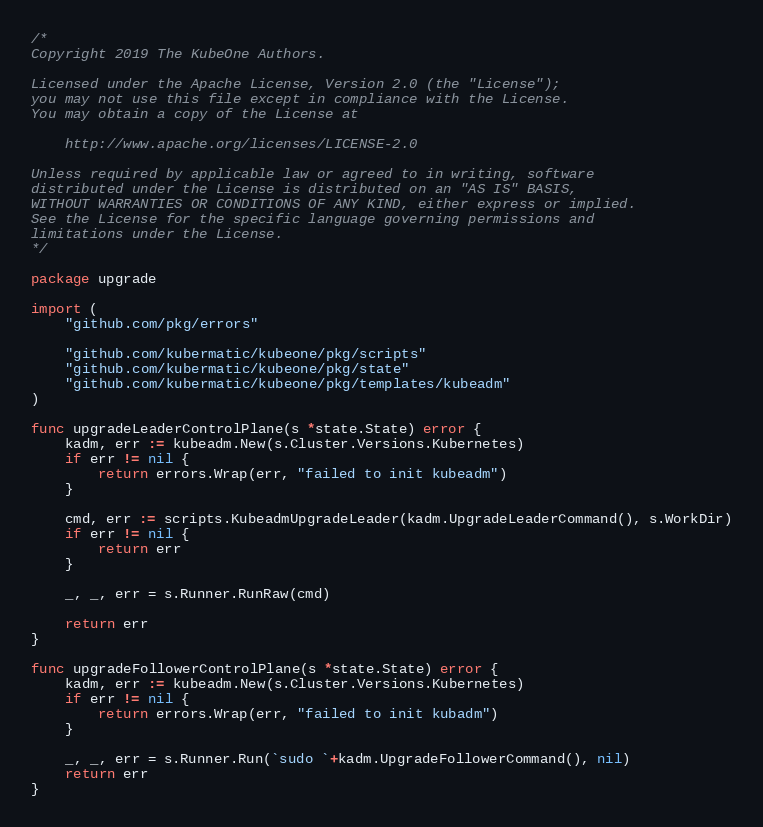Convert code to text. <code><loc_0><loc_0><loc_500><loc_500><_Go_>/*
Copyright 2019 The KubeOne Authors.

Licensed under the Apache License, Version 2.0 (the "License");
you may not use this file except in compliance with the License.
You may obtain a copy of the License at

    http://www.apache.org/licenses/LICENSE-2.0

Unless required by applicable law or agreed to in writing, software
distributed under the License is distributed on an "AS IS" BASIS,
WITHOUT WARRANTIES OR CONDITIONS OF ANY KIND, either express or implied.
See the License for the specific language governing permissions and
limitations under the License.
*/

package upgrade

import (
	"github.com/pkg/errors"

	"github.com/kubermatic/kubeone/pkg/scripts"
	"github.com/kubermatic/kubeone/pkg/state"
	"github.com/kubermatic/kubeone/pkg/templates/kubeadm"
)

func upgradeLeaderControlPlane(s *state.State) error {
	kadm, err := kubeadm.New(s.Cluster.Versions.Kubernetes)
	if err != nil {
		return errors.Wrap(err, "failed to init kubeadm")
	}

	cmd, err := scripts.KubeadmUpgradeLeader(kadm.UpgradeLeaderCommand(), s.WorkDir)
	if err != nil {
		return err
	}

	_, _, err = s.Runner.RunRaw(cmd)

	return err
}

func upgradeFollowerControlPlane(s *state.State) error {
	kadm, err := kubeadm.New(s.Cluster.Versions.Kubernetes)
	if err != nil {
		return errors.Wrap(err, "failed to init kubadm")
	}

	_, _, err = s.Runner.Run(`sudo `+kadm.UpgradeFollowerCommand(), nil)
	return err
}
</code> 